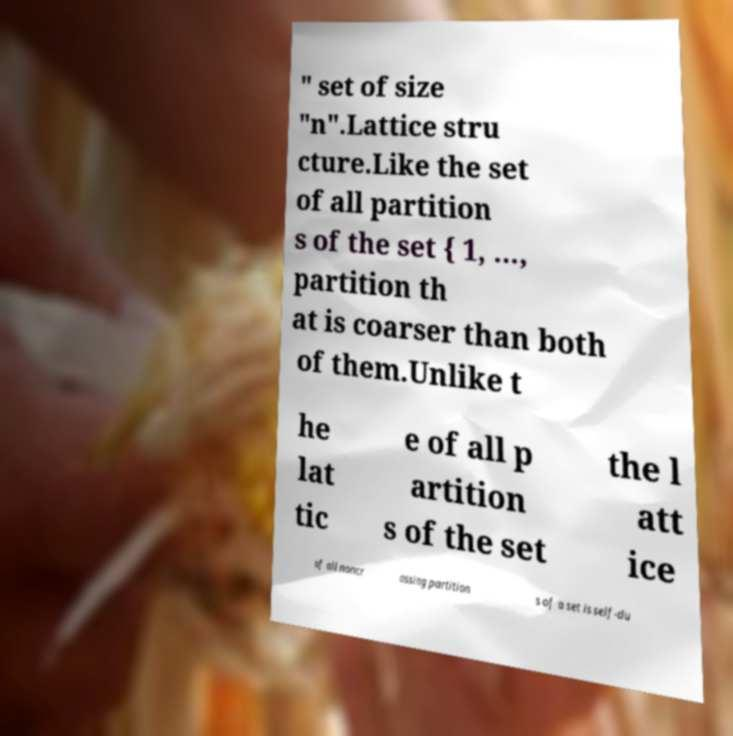Please identify and transcribe the text found in this image. " set of size "n".Lattice stru cture.Like the set of all partition s of the set { 1, ..., partition th at is coarser than both of them.Unlike t he lat tic e of all p artition s of the set the l att ice of all noncr ossing partition s of a set is self-du 